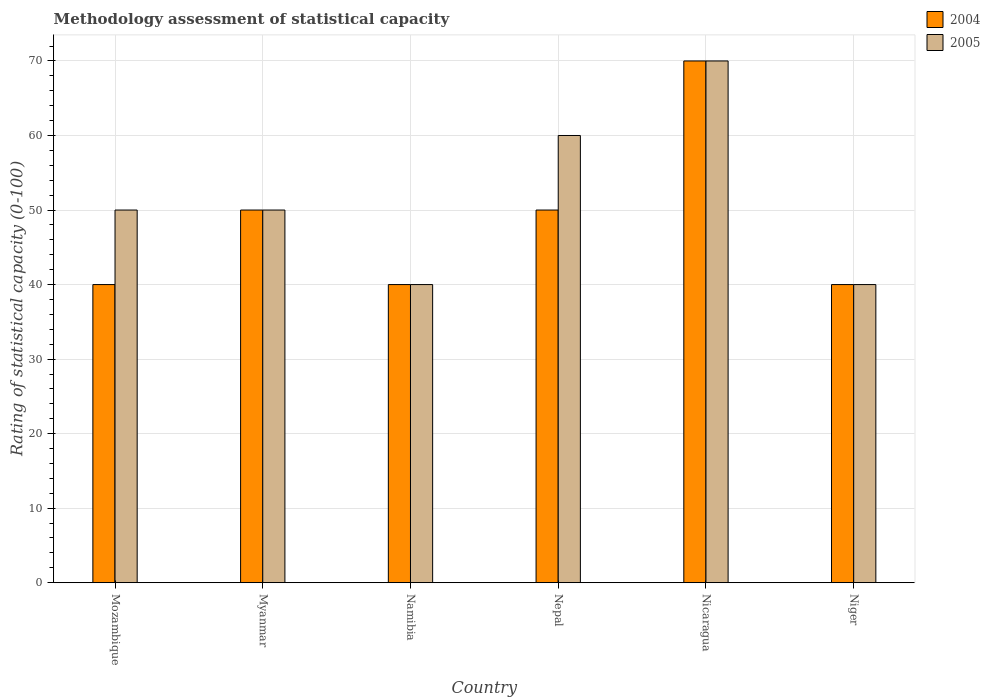How many different coloured bars are there?
Make the answer very short. 2. Are the number of bars per tick equal to the number of legend labels?
Offer a terse response. Yes. Are the number of bars on each tick of the X-axis equal?
Provide a short and direct response. Yes. How many bars are there on the 2nd tick from the right?
Provide a short and direct response. 2. What is the label of the 2nd group of bars from the left?
Ensure brevity in your answer.  Myanmar. In how many cases, is the number of bars for a given country not equal to the number of legend labels?
Offer a very short reply. 0. In which country was the rating of statistical capacity in 2004 maximum?
Your answer should be compact. Nicaragua. In which country was the rating of statistical capacity in 2004 minimum?
Your response must be concise. Mozambique. What is the total rating of statistical capacity in 2005 in the graph?
Your response must be concise. 310. What is the difference between the rating of statistical capacity in 2004 in Nepal and that in Nicaragua?
Provide a succinct answer. -20. What is the difference between the rating of statistical capacity in 2005 in Mozambique and the rating of statistical capacity in 2004 in Namibia?
Offer a very short reply. 10. What is the average rating of statistical capacity in 2004 per country?
Offer a very short reply. 48.33. In how many countries, is the rating of statistical capacity in 2005 greater than 56?
Your answer should be very brief. 2. Is the rating of statistical capacity in 2005 in Nepal less than that in Niger?
Give a very brief answer. No. What is the difference between the highest and the lowest rating of statistical capacity in 2005?
Your answer should be compact. 30. In how many countries, is the rating of statistical capacity in 2005 greater than the average rating of statistical capacity in 2005 taken over all countries?
Give a very brief answer. 2. Is the sum of the rating of statistical capacity in 2005 in Myanmar and Niger greater than the maximum rating of statistical capacity in 2004 across all countries?
Offer a terse response. Yes. What does the 1st bar from the right in Myanmar represents?
Provide a succinct answer. 2005. How many bars are there?
Offer a terse response. 12. Are all the bars in the graph horizontal?
Give a very brief answer. No. How many countries are there in the graph?
Provide a short and direct response. 6. What is the difference between two consecutive major ticks on the Y-axis?
Offer a terse response. 10. Are the values on the major ticks of Y-axis written in scientific E-notation?
Give a very brief answer. No. Does the graph contain any zero values?
Keep it short and to the point. No. Where does the legend appear in the graph?
Ensure brevity in your answer.  Top right. How many legend labels are there?
Offer a terse response. 2. What is the title of the graph?
Keep it short and to the point. Methodology assessment of statistical capacity. Does "1966" appear as one of the legend labels in the graph?
Provide a short and direct response. No. What is the label or title of the X-axis?
Make the answer very short. Country. What is the label or title of the Y-axis?
Provide a short and direct response. Rating of statistical capacity (0-100). What is the Rating of statistical capacity (0-100) of 2005 in Mozambique?
Keep it short and to the point. 50. What is the Rating of statistical capacity (0-100) in 2004 in Myanmar?
Your response must be concise. 50. What is the Rating of statistical capacity (0-100) in 2005 in Myanmar?
Ensure brevity in your answer.  50. What is the Rating of statistical capacity (0-100) in 2004 in Namibia?
Your answer should be very brief. 40. What is the Rating of statistical capacity (0-100) of 2005 in Nepal?
Ensure brevity in your answer.  60. What is the Rating of statistical capacity (0-100) of 2004 in Nicaragua?
Your response must be concise. 70. What is the Rating of statistical capacity (0-100) of 2004 in Niger?
Your answer should be compact. 40. What is the Rating of statistical capacity (0-100) of 2005 in Niger?
Your answer should be very brief. 40. Across all countries, what is the maximum Rating of statistical capacity (0-100) of 2004?
Provide a short and direct response. 70. Across all countries, what is the maximum Rating of statistical capacity (0-100) of 2005?
Offer a very short reply. 70. Across all countries, what is the minimum Rating of statistical capacity (0-100) of 2004?
Your response must be concise. 40. What is the total Rating of statistical capacity (0-100) in 2004 in the graph?
Ensure brevity in your answer.  290. What is the total Rating of statistical capacity (0-100) of 2005 in the graph?
Give a very brief answer. 310. What is the difference between the Rating of statistical capacity (0-100) of 2004 in Mozambique and that in Myanmar?
Ensure brevity in your answer.  -10. What is the difference between the Rating of statistical capacity (0-100) of 2005 in Mozambique and that in Myanmar?
Offer a very short reply. 0. What is the difference between the Rating of statistical capacity (0-100) in 2004 in Mozambique and that in Namibia?
Your answer should be compact. 0. What is the difference between the Rating of statistical capacity (0-100) in 2004 in Mozambique and that in Nepal?
Offer a terse response. -10. What is the difference between the Rating of statistical capacity (0-100) in 2005 in Mozambique and that in Nepal?
Provide a short and direct response. -10. What is the difference between the Rating of statistical capacity (0-100) of 2004 in Mozambique and that in Niger?
Your answer should be very brief. 0. What is the difference between the Rating of statistical capacity (0-100) in 2004 in Myanmar and that in Namibia?
Your response must be concise. 10. What is the difference between the Rating of statistical capacity (0-100) of 2005 in Myanmar and that in Namibia?
Ensure brevity in your answer.  10. What is the difference between the Rating of statistical capacity (0-100) of 2004 in Myanmar and that in Nepal?
Your response must be concise. 0. What is the difference between the Rating of statistical capacity (0-100) of 2005 in Myanmar and that in Nepal?
Make the answer very short. -10. What is the difference between the Rating of statistical capacity (0-100) of 2005 in Myanmar and that in Nicaragua?
Make the answer very short. -20. What is the difference between the Rating of statistical capacity (0-100) of 2005 in Namibia and that in Niger?
Keep it short and to the point. 0. What is the difference between the Rating of statistical capacity (0-100) of 2005 in Nepal and that in Nicaragua?
Your answer should be very brief. -10. What is the difference between the Rating of statistical capacity (0-100) in 2004 in Nepal and that in Niger?
Your answer should be very brief. 10. What is the difference between the Rating of statistical capacity (0-100) of 2005 in Nepal and that in Niger?
Your answer should be compact. 20. What is the difference between the Rating of statistical capacity (0-100) in 2004 in Nicaragua and that in Niger?
Ensure brevity in your answer.  30. What is the difference between the Rating of statistical capacity (0-100) of 2004 in Mozambique and the Rating of statistical capacity (0-100) of 2005 in Myanmar?
Your answer should be very brief. -10. What is the difference between the Rating of statistical capacity (0-100) in 2004 in Mozambique and the Rating of statistical capacity (0-100) in 2005 in Nepal?
Ensure brevity in your answer.  -20. What is the difference between the Rating of statistical capacity (0-100) in 2004 in Mozambique and the Rating of statistical capacity (0-100) in 2005 in Nicaragua?
Keep it short and to the point. -30. What is the difference between the Rating of statistical capacity (0-100) of 2004 in Mozambique and the Rating of statistical capacity (0-100) of 2005 in Niger?
Keep it short and to the point. 0. What is the difference between the Rating of statistical capacity (0-100) in 2004 in Namibia and the Rating of statistical capacity (0-100) in 2005 in Nepal?
Make the answer very short. -20. What is the difference between the Rating of statistical capacity (0-100) in 2004 in Namibia and the Rating of statistical capacity (0-100) in 2005 in Nicaragua?
Your response must be concise. -30. What is the difference between the Rating of statistical capacity (0-100) in 2004 in Nepal and the Rating of statistical capacity (0-100) in 2005 in Nicaragua?
Your answer should be very brief. -20. What is the difference between the Rating of statistical capacity (0-100) of 2004 in Nepal and the Rating of statistical capacity (0-100) of 2005 in Niger?
Make the answer very short. 10. What is the average Rating of statistical capacity (0-100) in 2004 per country?
Give a very brief answer. 48.33. What is the average Rating of statistical capacity (0-100) in 2005 per country?
Give a very brief answer. 51.67. What is the difference between the Rating of statistical capacity (0-100) in 2004 and Rating of statistical capacity (0-100) in 2005 in Mozambique?
Your answer should be very brief. -10. What is the difference between the Rating of statistical capacity (0-100) in 2004 and Rating of statistical capacity (0-100) in 2005 in Nepal?
Provide a succinct answer. -10. What is the difference between the Rating of statistical capacity (0-100) in 2004 and Rating of statistical capacity (0-100) in 2005 in Nicaragua?
Offer a very short reply. 0. What is the difference between the Rating of statistical capacity (0-100) in 2004 and Rating of statistical capacity (0-100) in 2005 in Niger?
Offer a very short reply. 0. What is the ratio of the Rating of statistical capacity (0-100) in 2004 in Mozambique to that in Myanmar?
Make the answer very short. 0.8. What is the ratio of the Rating of statistical capacity (0-100) of 2005 in Mozambique to that in Namibia?
Keep it short and to the point. 1.25. What is the ratio of the Rating of statistical capacity (0-100) in 2004 in Mozambique to that in Nepal?
Provide a short and direct response. 0.8. What is the ratio of the Rating of statistical capacity (0-100) in 2005 in Mozambique to that in Nepal?
Your answer should be very brief. 0.83. What is the ratio of the Rating of statistical capacity (0-100) in 2005 in Mozambique to that in Nicaragua?
Your response must be concise. 0.71. What is the ratio of the Rating of statistical capacity (0-100) in 2004 in Myanmar to that in Namibia?
Ensure brevity in your answer.  1.25. What is the ratio of the Rating of statistical capacity (0-100) in 2004 in Myanmar to that in Nepal?
Provide a short and direct response. 1. What is the ratio of the Rating of statistical capacity (0-100) in 2005 in Myanmar to that in Nicaragua?
Offer a very short reply. 0.71. What is the ratio of the Rating of statistical capacity (0-100) of 2004 in Myanmar to that in Niger?
Offer a very short reply. 1.25. What is the ratio of the Rating of statistical capacity (0-100) of 2005 in Namibia to that in Nepal?
Your response must be concise. 0.67. What is the ratio of the Rating of statistical capacity (0-100) of 2005 in Namibia to that in Nicaragua?
Offer a very short reply. 0.57. What is the ratio of the Rating of statistical capacity (0-100) of 2004 in Namibia to that in Niger?
Give a very brief answer. 1. What is the ratio of the Rating of statistical capacity (0-100) in 2005 in Nepal to that in Nicaragua?
Give a very brief answer. 0.86. What is the ratio of the Rating of statistical capacity (0-100) of 2004 in Nepal to that in Niger?
Keep it short and to the point. 1.25. What is the ratio of the Rating of statistical capacity (0-100) of 2004 in Nicaragua to that in Niger?
Give a very brief answer. 1.75. What is the difference between the highest and the second highest Rating of statistical capacity (0-100) of 2005?
Give a very brief answer. 10. What is the difference between the highest and the lowest Rating of statistical capacity (0-100) of 2005?
Your answer should be compact. 30. 